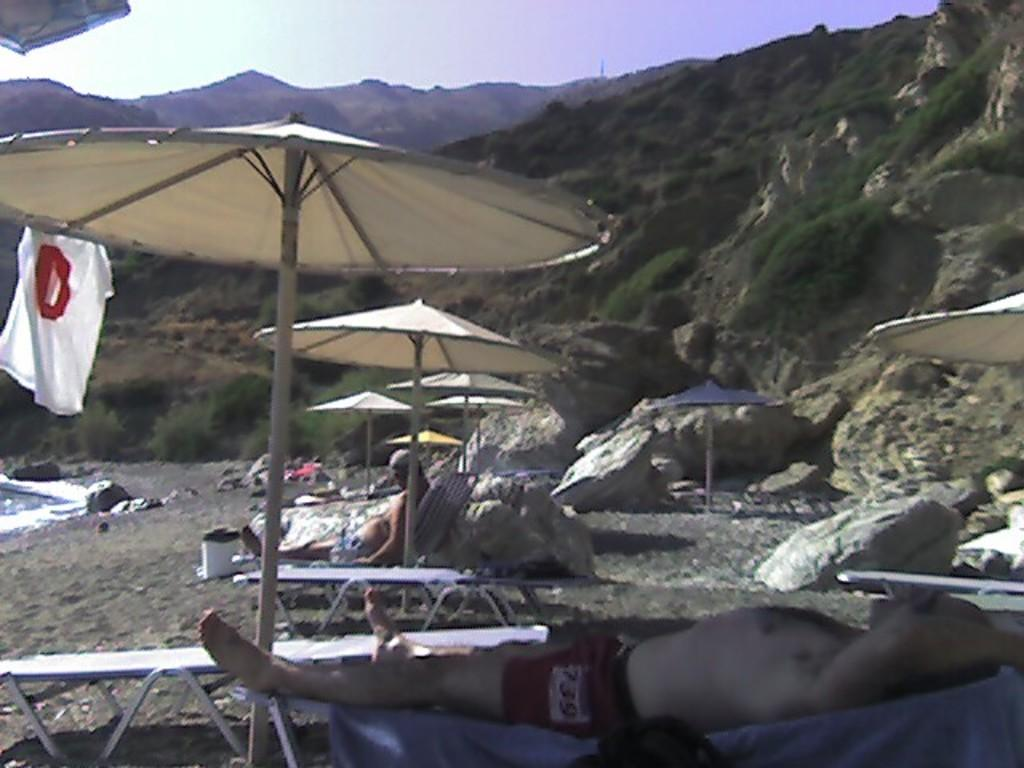Who or what can be seen in the image? There are people in the image. What are the people doing in the image? The people are under umbrellas. What can be seen in the distance in the image? There are hills visible in the background of the image. What else is visible in the background of the image? The sky is visible in the background of the image. What type of pot is being traded by the ghost in the image? There is no pot or ghost present in the image. 